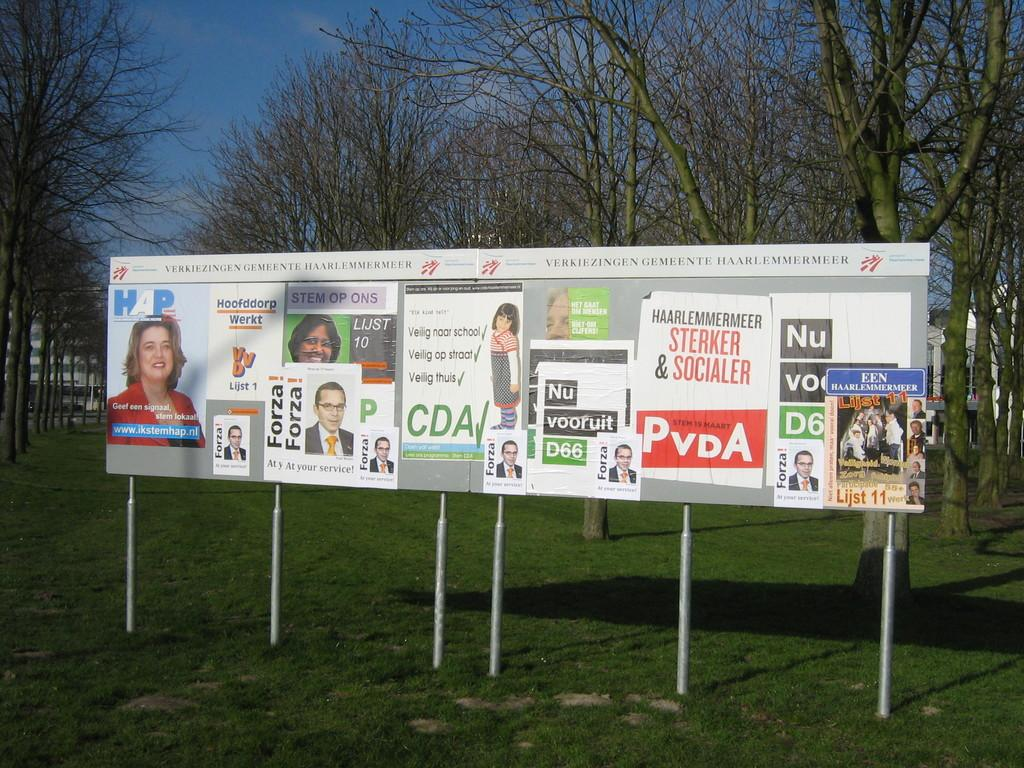<image>
Write a terse but informative summary of the picture. a board with many signs on it and a CDA paper 